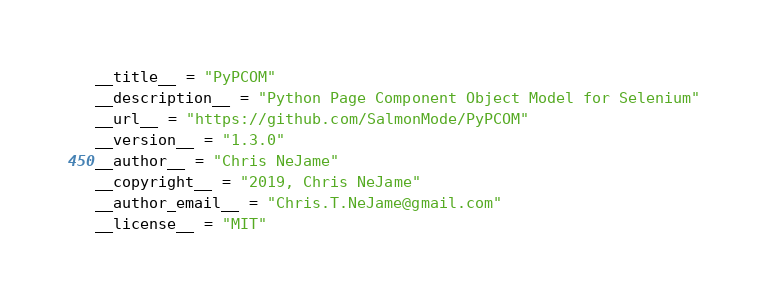<code> <loc_0><loc_0><loc_500><loc_500><_Python_>__title__ = "PyPCOM"
__description__ = "Python Page Component Object Model for Selenium"
__url__ = "https://github.com/SalmonMode/PyPCOM"
__version__ = "1.3.0"
__author__ = "Chris NeJame"
__copyright__ = "2019, Chris NeJame"
__author_email__ = "Chris.T.NeJame@gmail.com"
__license__ = "MIT"
</code> 